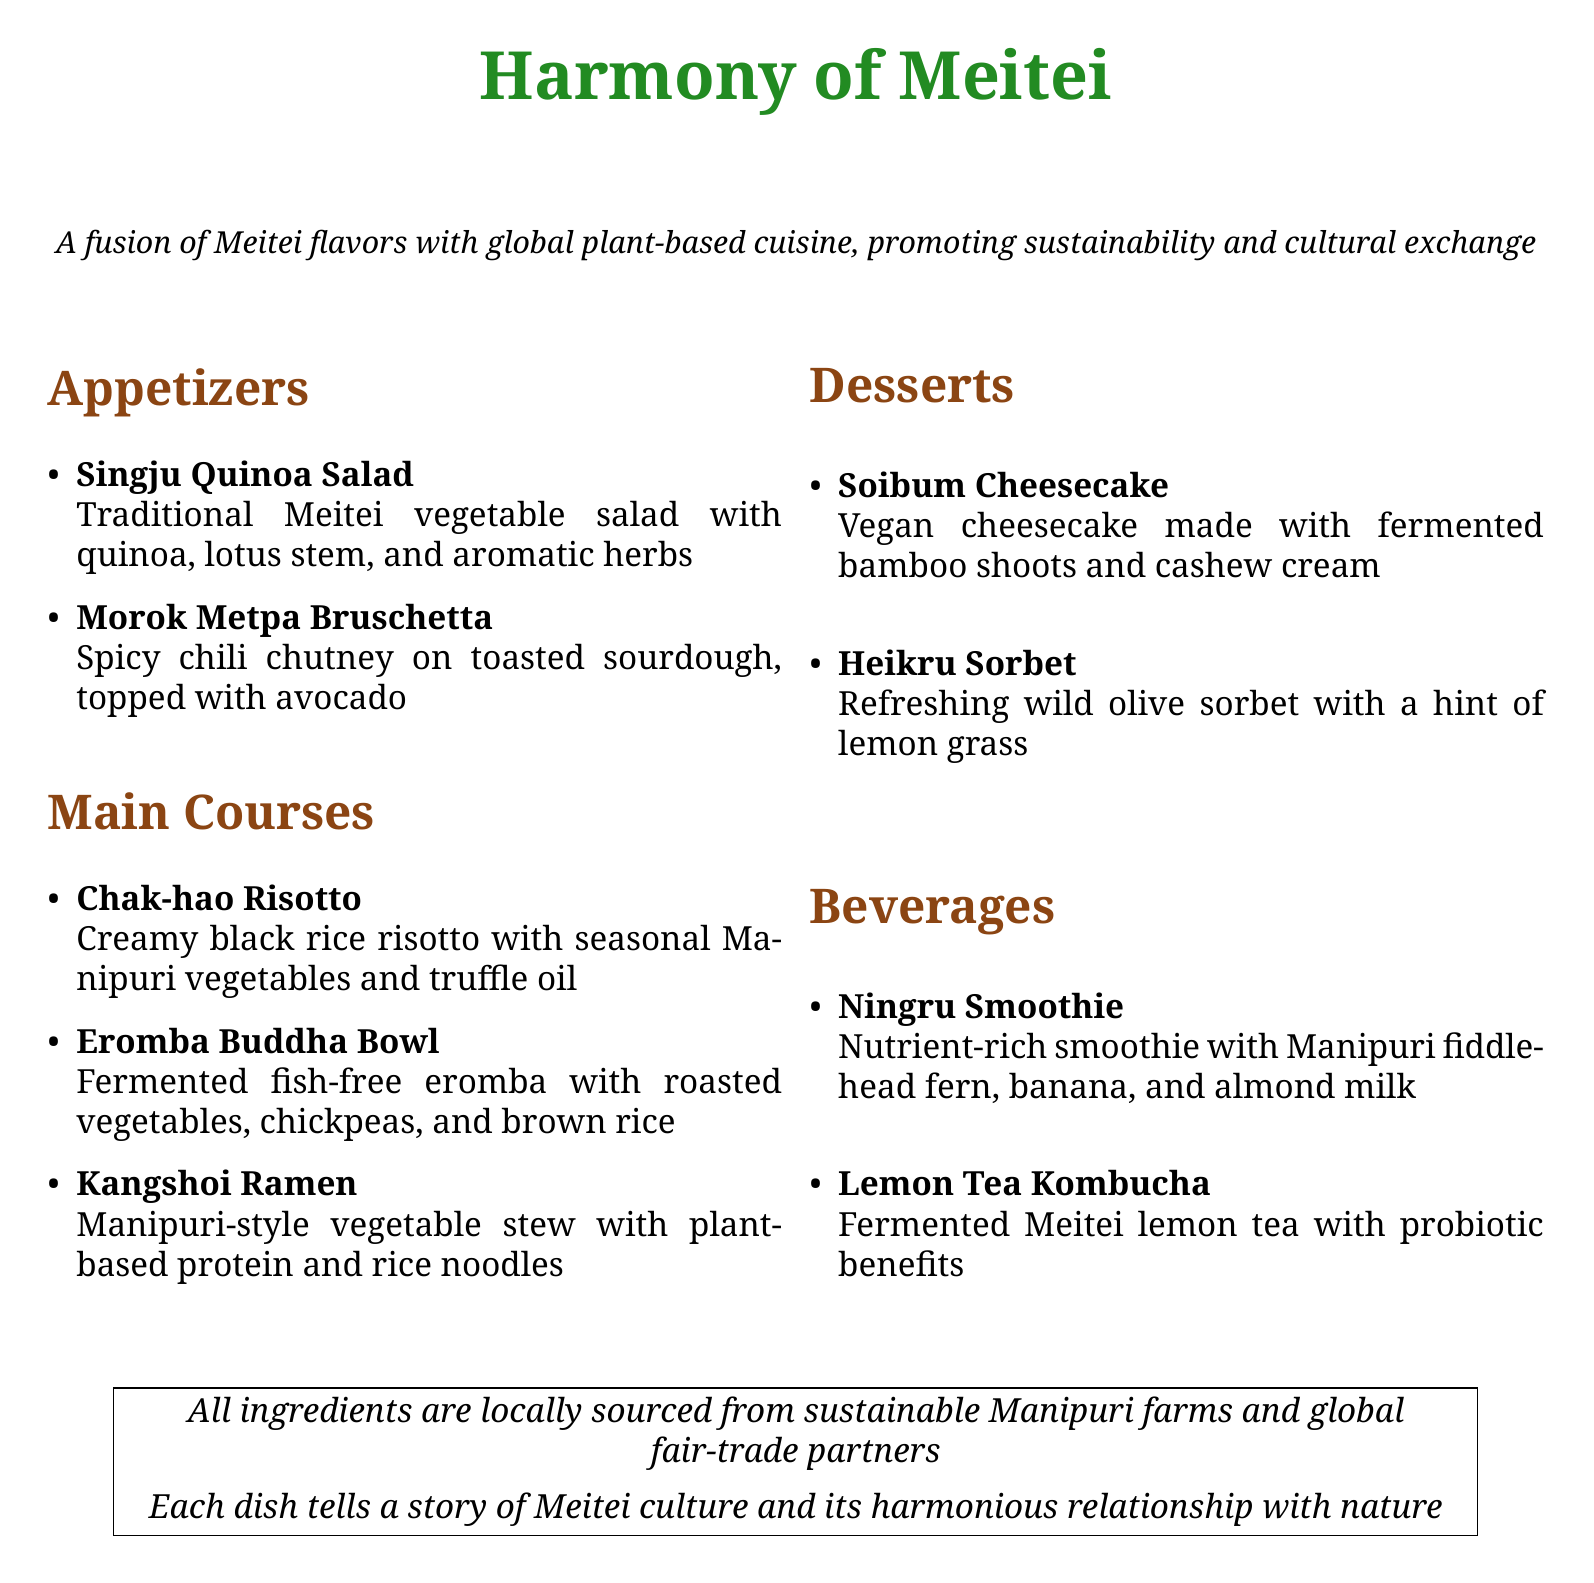What is the name of the restaurant? The name of the restaurant is mentioned at the top of the document in a larger font.
Answer: Harmony of Meitei What type of cuisine is offered? The document describes the cuisine as a fusion of Meitei flavors with global plant-based cuisine.
Answer: Fusion of Meitei flavors with global plant-based cuisine How many appetizers are listed in the menu? By counting the items under the Appetizers section, we find there are two appetizers listed.
Answer: 2 What is the main ingredient in the Chak-hao Risotto? The main ingredient in the Chak-hao Risotto is mentioned in the dish description.
Answer: Black rice Which dessert includes fermented bamboo shoots? The dessert description indicates that the Soibum Cheesecake is made with fermented bamboo shoots.
Answer: Soibum Cheesecake What type of smoothie is offered? The menu specifies the type of smoothie as a Ningru Smoothie.
Answer: Ningru Smoothie What unique ingredient is used in the Heikru Sorbet? The Heikru Sorbet description highlights wild olive as the unique ingredient.
Answer: Wild olive Is the sourced food sustainable? The document contains a note indicating that all ingredients are locally sourced from sustainable farms.
Answer: Yes What kind of tea is included in the beverages? The beverage menu includes a fermented Meitei lemon tea as a drink option.
Answer: Lemon Tea Kombucha 